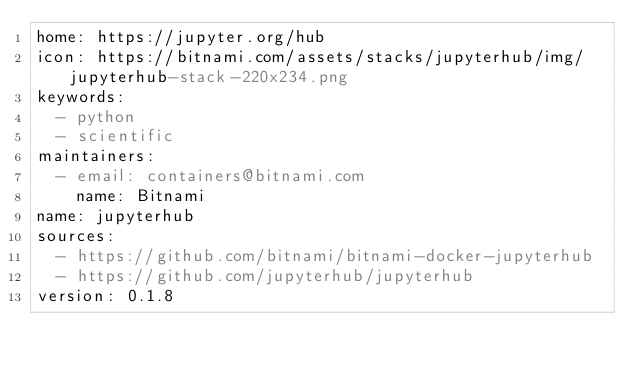Convert code to text. <code><loc_0><loc_0><loc_500><loc_500><_YAML_>home: https://jupyter.org/hub
icon: https://bitnami.com/assets/stacks/jupyterhub/img/jupyterhub-stack-220x234.png
keywords:
  - python
  - scientific
maintainers:
  - email: containers@bitnami.com
    name: Bitnami
name: jupyterhub
sources:
  - https://github.com/bitnami/bitnami-docker-jupyterhub
  - https://github.com/jupyterhub/jupyterhub
version: 0.1.8
</code> 